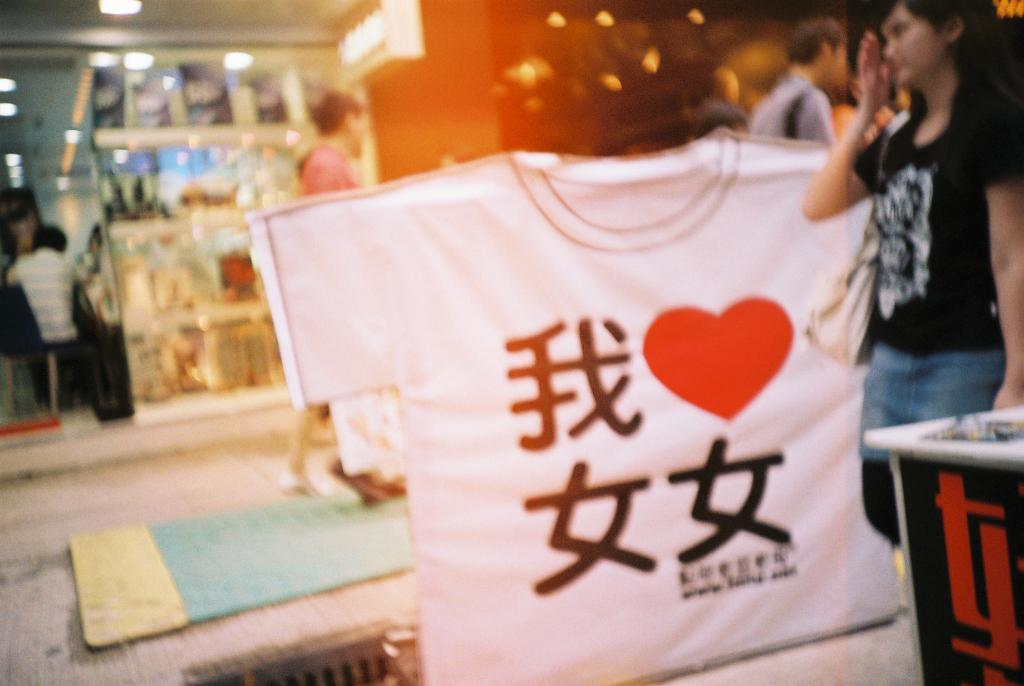How many people are in the image? There are people in the image, but the exact number is not specified. What is located in the center of the image? There is a board in the center of the image. What is on the right side of the image? There is a table on the right side of the image. What can be seen in the background of the image? There are lights and walls visible in the background of the image. What type of flooring is present in the image? There is a mat in the image. How many parcels are being delivered by the giraffe in the image? There is no giraffe or parcel present in the image. What type of power source is visible in the image? There is no power source visible in the image. 